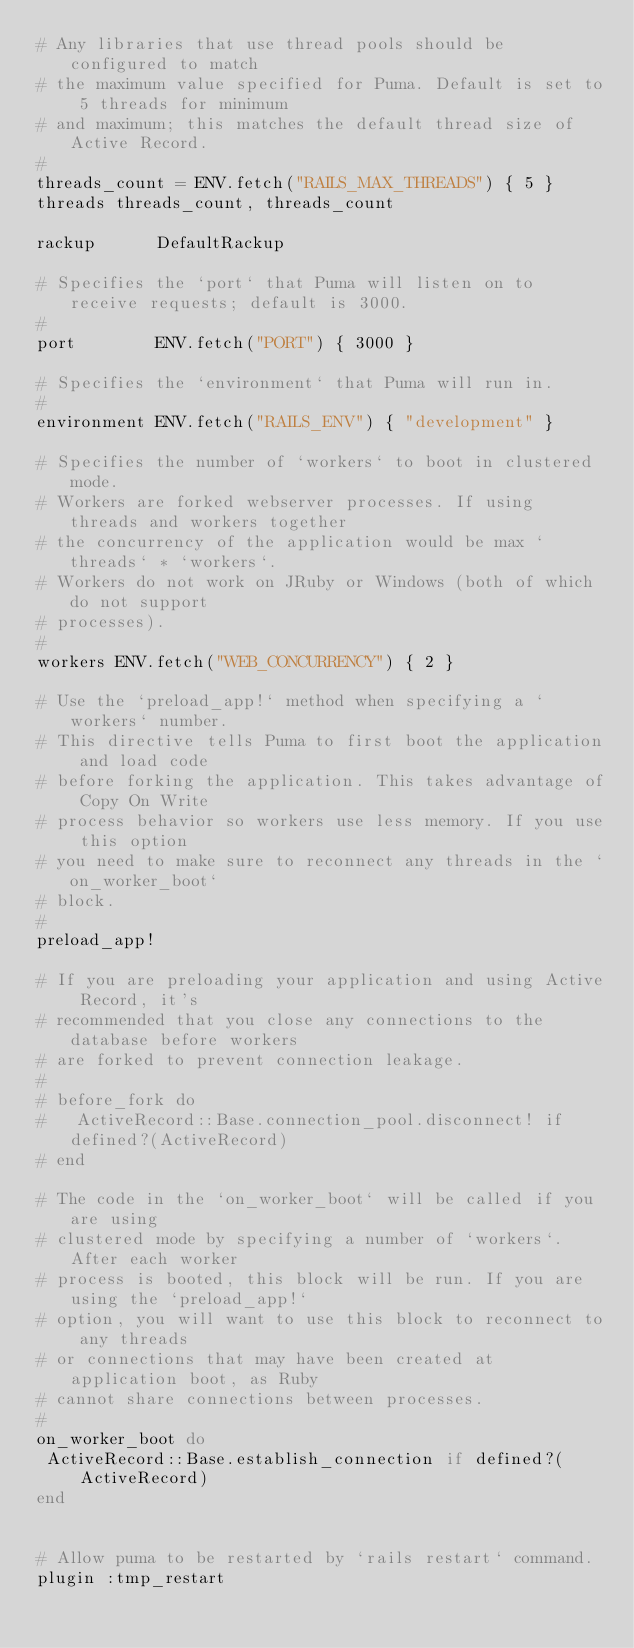Convert code to text. <code><loc_0><loc_0><loc_500><loc_500><_Ruby_># Any libraries that use thread pools should be configured to match
# the maximum value specified for Puma. Default is set to 5 threads for minimum
# and maximum; this matches the default thread size of Active Record.
#
threads_count = ENV.fetch("RAILS_MAX_THREADS") { 5 }
threads threads_count, threads_count

rackup      DefaultRackup

# Specifies the `port` that Puma will listen on to receive requests; default is 3000.
#
port        ENV.fetch("PORT") { 3000 }

# Specifies the `environment` that Puma will run in.
#
environment ENV.fetch("RAILS_ENV") { "development" }

# Specifies the number of `workers` to boot in clustered mode.
# Workers are forked webserver processes. If using threads and workers together
# the concurrency of the application would be max `threads` * `workers`.
# Workers do not work on JRuby or Windows (both of which do not support
# processes).
#
workers ENV.fetch("WEB_CONCURRENCY") { 2 }

# Use the `preload_app!` method when specifying a `workers` number.
# This directive tells Puma to first boot the application and load code
# before forking the application. This takes advantage of Copy On Write
# process behavior so workers use less memory. If you use this option
# you need to make sure to reconnect any threads in the `on_worker_boot`
# block.
#
preload_app!

# If you are preloading your application and using Active Record, it's
# recommended that you close any connections to the database before workers
# are forked to prevent connection leakage.
#
# before_fork do
#   ActiveRecord::Base.connection_pool.disconnect! if defined?(ActiveRecord)
# end

# The code in the `on_worker_boot` will be called if you are using
# clustered mode by specifying a number of `workers`. After each worker
# process is booted, this block will be run. If you are using the `preload_app!`
# option, you will want to use this block to reconnect to any threads
# or connections that may have been created at application boot, as Ruby
# cannot share connections between processes.
#
on_worker_boot do
 ActiveRecord::Base.establish_connection if defined?(ActiveRecord)
end


# Allow puma to be restarted by `rails restart` command.
plugin :tmp_restart
</code> 